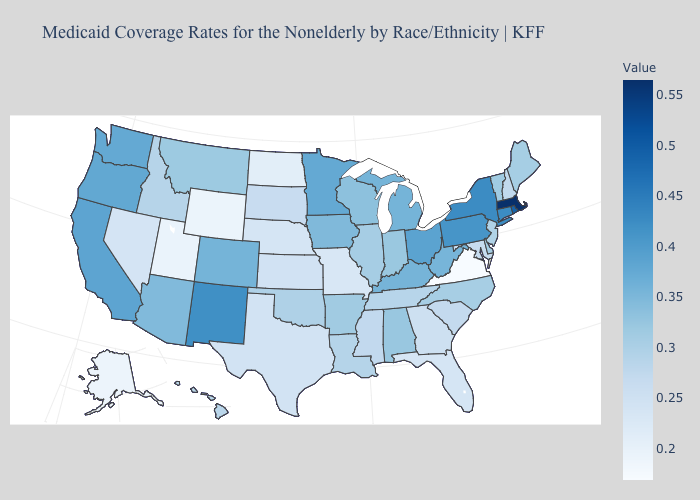Which states have the lowest value in the USA?
Answer briefly. Virginia. Among the states that border Delaware , does New Jersey have the highest value?
Concise answer only. No. Among the states that border Vermont , does New Hampshire have the lowest value?
Be succinct. Yes. Does Arkansas have a higher value than Kentucky?
Keep it brief. No. Which states have the highest value in the USA?
Answer briefly. Massachusetts. Among the states that border Massachusetts , does Rhode Island have the lowest value?
Answer briefly. No. Which states hav the highest value in the South?
Give a very brief answer. Kentucky. 